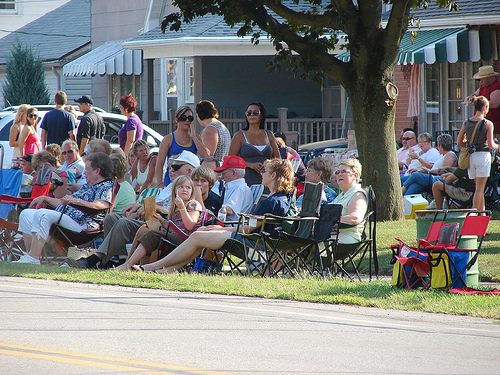<image>
Is there a house in front of the women? No. The house is not in front of the women. The spatial positioning shows a different relationship between these objects. 